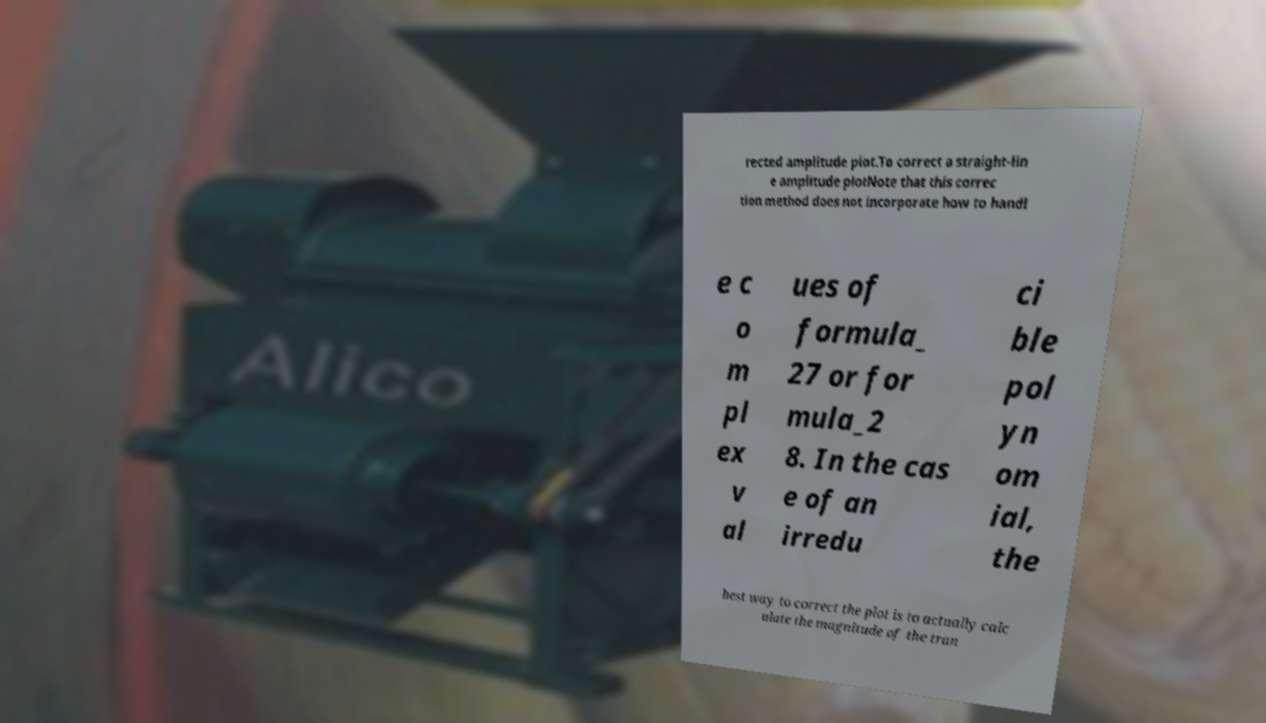Could you extract and type out the text from this image? rected amplitude plot.To correct a straight-lin e amplitude plotNote that this correc tion method does not incorporate how to handl e c o m pl ex v al ues of formula_ 27 or for mula_2 8. In the cas e of an irredu ci ble pol yn om ial, the best way to correct the plot is to actually calc ulate the magnitude of the tran 